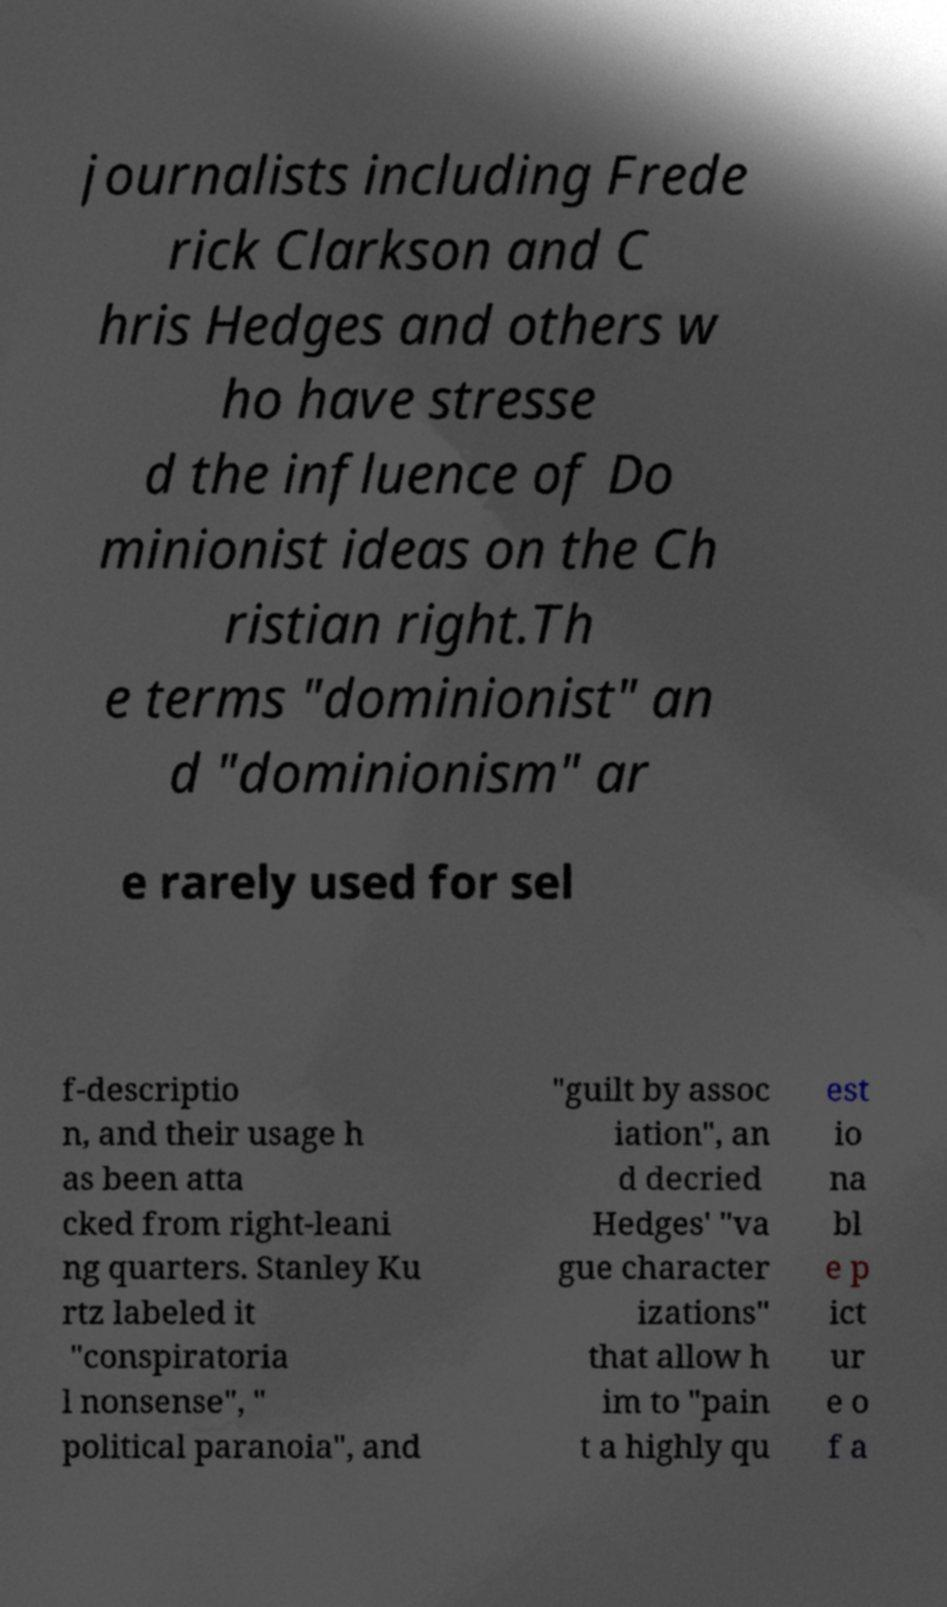There's text embedded in this image that I need extracted. Can you transcribe it verbatim? journalists including Frede rick Clarkson and C hris Hedges and others w ho have stresse d the influence of Do minionist ideas on the Ch ristian right.Th e terms "dominionist" an d "dominionism" ar e rarely used for sel f-descriptio n, and their usage h as been atta cked from right-leani ng quarters. Stanley Ku rtz labeled it "conspiratoria l nonsense", " political paranoia", and "guilt by assoc iation", an d decried Hedges' "va gue character izations" that allow h im to "pain t a highly qu est io na bl e p ict ur e o f a 